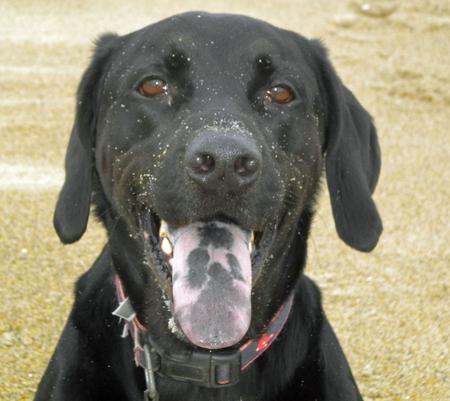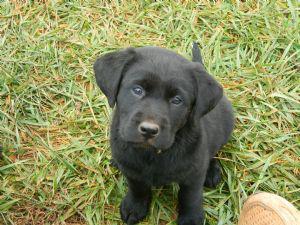The first image is the image on the left, the second image is the image on the right. Evaluate the accuracy of this statement regarding the images: "In one image, one adult dog has its mouth open showing its tongue and is wearing a collar, while a second image shows a sitting puppy of the same breed.". Is it true? Answer yes or no. Yes. 